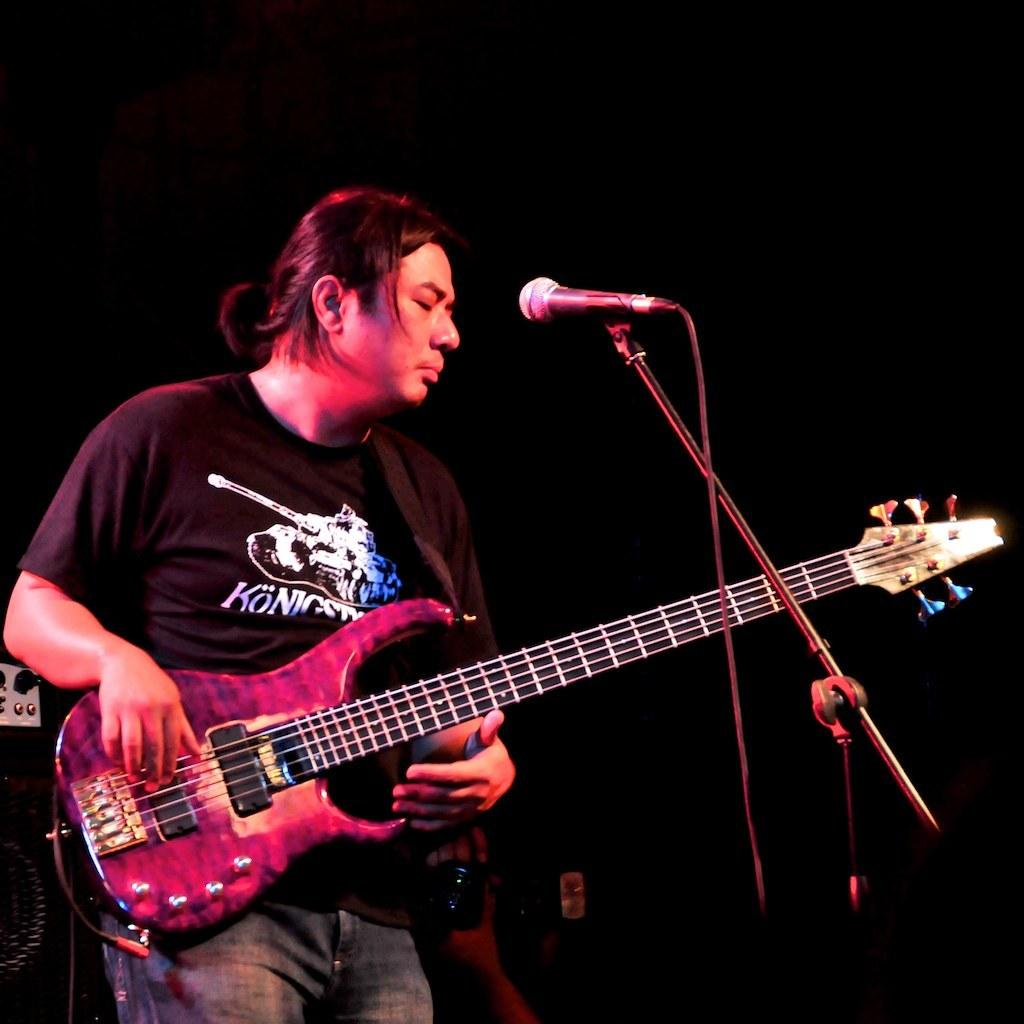What is the main subject of the image? The main subject of the image is a man. What is the man doing in the image? The man is standing and playing a guitar. What is in front of the man? There is a microphone in front of the man. What is the man wearing in the image? The man is wearing a black t-shirt. How would you describe the background of the image? The background of the image is dark. What year is the man's parent celebrating their birthday in the image? There is no information about a birthday or a parent in the image, so it is impossible to determine the year. 